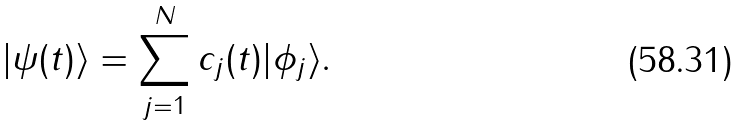<formula> <loc_0><loc_0><loc_500><loc_500>| \psi ( t ) \rangle = \sum _ { j = 1 } ^ { N } c _ { j } ( t ) | \phi _ { j } \rangle .</formula> 